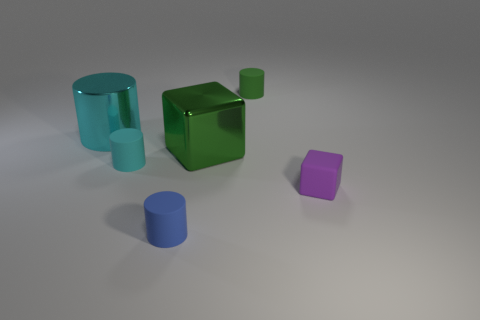There is a cube that is behind the object on the right side of the green rubber cylinder; what is its color?
Offer a very short reply. Green. What number of other objects are there of the same material as the tiny blue thing?
Give a very brief answer. 3. How many other things are the same color as the metallic block?
Your response must be concise. 1. The small cylinder that is on the left side of the tiny matte cylinder in front of the purple object is made of what material?
Make the answer very short. Rubber. Is there a large metallic cylinder?
Offer a very short reply. Yes. There is a rubber thing that is left of the small matte cylinder that is in front of the tiny purple matte block; what is its size?
Your answer should be very brief. Small. Is the number of blocks that are behind the small green rubber cylinder greater than the number of things behind the big cube?
Offer a terse response. No. What number of cubes are large green things or tiny blue matte objects?
Your answer should be very brief. 1. Is there any other thing that has the same size as the cyan matte object?
Your answer should be very brief. Yes. Do the matte thing behind the big cyan thing and the cyan shiny object have the same shape?
Your answer should be compact. Yes. 